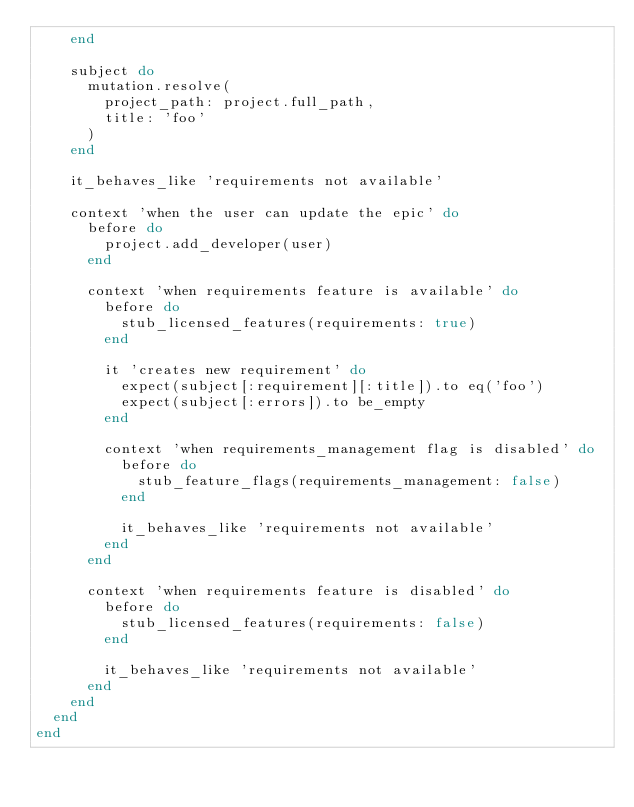<code> <loc_0><loc_0><loc_500><loc_500><_Ruby_>    end

    subject do
      mutation.resolve(
        project_path: project.full_path,
        title: 'foo'
      )
    end

    it_behaves_like 'requirements not available'

    context 'when the user can update the epic' do
      before do
        project.add_developer(user)
      end

      context 'when requirements feature is available' do
        before do
          stub_licensed_features(requirements: true)
        end

        it 'creates new requirement' do
          expect(subject[:requirement][:title]).to eq('foo')
          expect(subject[:errors]).to be_empty
        end

        context 'when requirements_management flag is disabled' do
          before do
            stub_feature_flags(requirements_management: false)
          end

          it_behaves_like 'requirements not available'
        end
      end

      context 'when requirements feature is disabled' do
        before do
          stub_licensed_features(requirements: false)
        end

        it_behaves_like 'requirements not available'
      end
    end
  end
end
</code> 